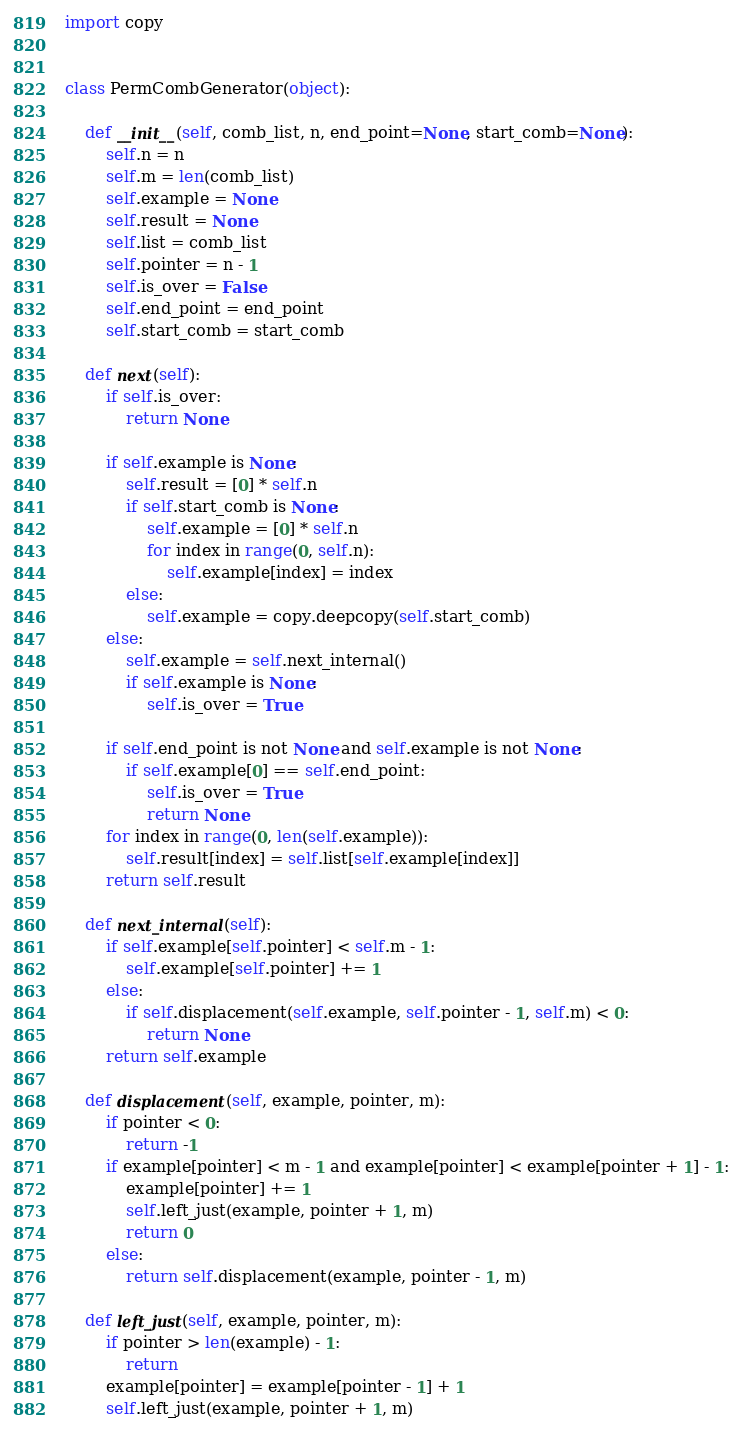Convert code to text. <code><loc_0><loc_0><loc_500><loc_500><_Python_>import copy


class PermCombGenerator(object):

    def __init__(self, comb_list, n, end_point=None, start_comb=None):
        self.n = n
        self.m = len(comb_list)
        self.example = None
        self.result = None
        self.list = comb_list
        self.pointer = n - 1
        self.is_over = False
        self.end_point = end_point
        self.start_comb = start_comb

    def next(self):
        if self.is_over:
            return None

        if self.example is None:
            self.result = [0] * self.n
            if self.start_comb is None:
                self.example = [0] * self.n
                for index in range(0, self.n):
                    self.example[index] = index
            else:
                self.example = copy.deepcopy(self.start_comb)
        else:
            self.example = self.next_internal()
            if self.example is None:
                self.is_over = True

        if self.end_point is not None and self.example is not None:
            if self.example[0] == self.end_point:
                self.is_over = True
                return None
        for index in range(0, len(self.example)):
            self.result[index] = self.list[self.example[index]]
        return self.result

    def next_internal(self):
        if self.example[self.pointer] < self.m - 1:
            self.example[self.pointer] += 1
        else:
            if self.displacement(self.example, self.pointer - 1, self.m) < 0:
                return None
        return self.example

    def displacement(self, example, pointer, m):
        if pointer < 0:
            return -1
        if example[pointer] < m - 1 and example[pointer] < example[pointer + 1] - 1:
            example[pointer] += 1
            self.left_just(example, pointer + 1, m)
            return 0
        else:
            return self.displacement(example, pointer - 1, m)

    def left_just(self, example, pointer, m):
        if pointer > len(example) - 1:
            return
        example[pointer] = example[pointer - 1] + 1
        self.left_just(example, pointer + 1, m)
</code> 